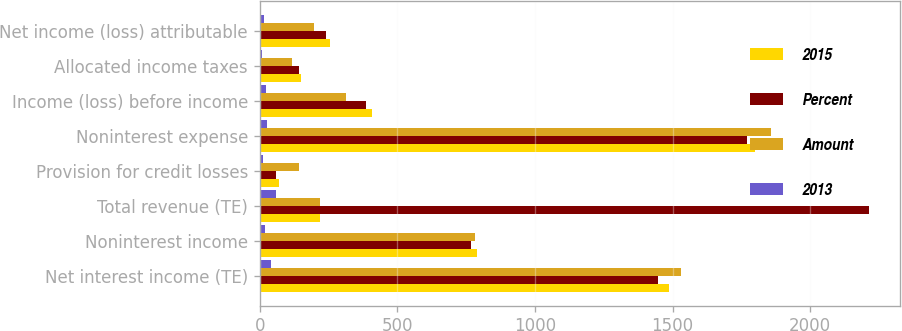<chart> <loc_0><loc_0><loc_500><loc_500><stacked_bar_chart><ecel><fcel>Net interest income (TE)<fcel>Noninterest income<fcel>Total revenue (TE)<fcel>Provision for credit losses<fcel>Noninterest expense<fcel>Income (loss) before income<fcel>Allocated income taxes<fcel>Net income (loss) attributable<nl><fcel>2015<fcel>1486<fcel>789<fcel>219.5<fcel>70<fcel>1798<fcel>407<fcel>151<fcel>256<nl><fcel>Percent<fcel>1446<fcel>769<fcel>2215<fcel>59<fcel>1771<fcel>385<fcel>143<fcel>242<nl><fcel>Amount<fcel>1531<fcel>784<fcel>219.5<fcel>143<fcel>1858<fcel>314<fcel>117<fcel>197<nl><fcel>2013<fcel>40<fcel>20<fcel>60<fcel>11<fcel>27<fcel>22<fcel>8<fcel>14<nl></chart> 